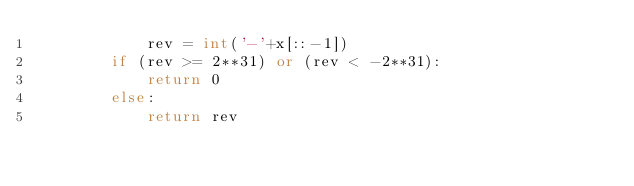Convert code to text. <code><loc_0><loc_0><loc_500><loc_500><_Python_>            rev = int('-'+x[::-1])
        if (rev >= 2**31) or (rev < -2**31):
            return 0
        else:
            return rev</code> 